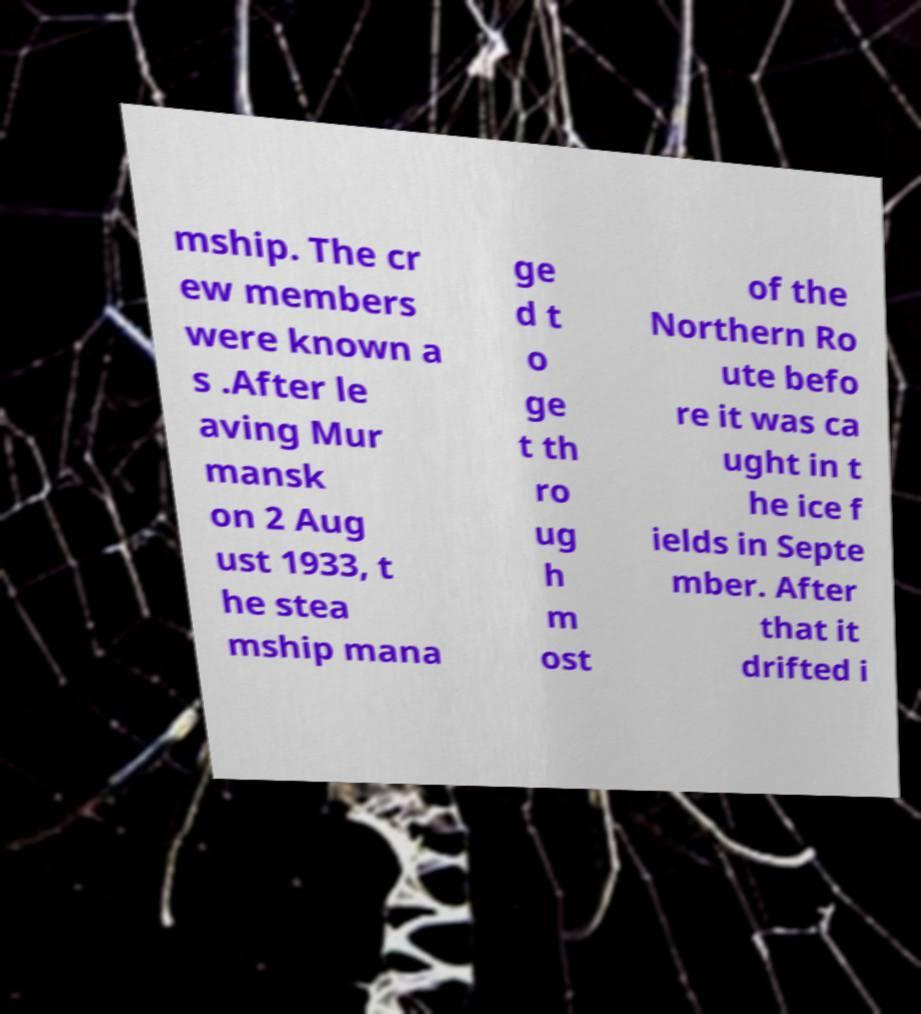Please identify and transcribe the text found in this image. mship. The cr ew members were known a s .After le aving Mur mansk on 2 Aug ust 1933, t he stea mship mana ge d t o ge t th ro ug h m ost of the Northern Ro ute befo re it was ca ught in t he ice f ields in Septe mber. After that it drifted i 